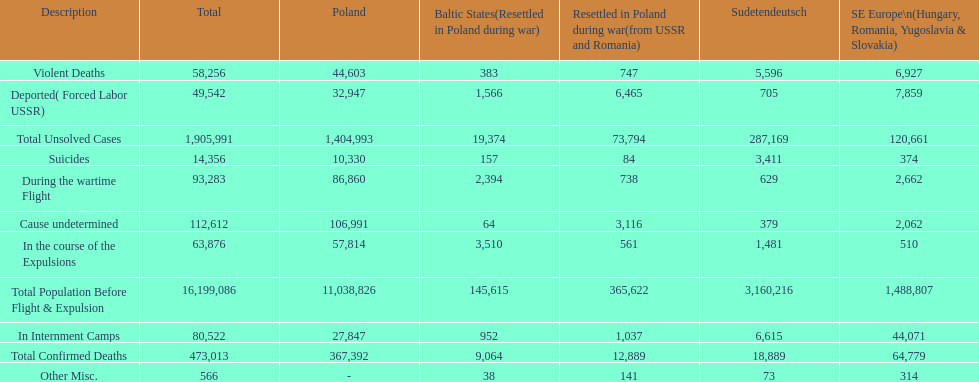What is the difference between suicides in poland and sudetendeutsch? 6919. Give me the full table as a dictionary. {'header': ['Description', 'Total', 'Poland', 'Baltic States(Resettled in Poland during war)', 'Resettled in Poland during war(from USSR and Romania)', 'Sudetendeutsch', 'SE Europe\\n(Hungary, Romania, Yugoslavia & Slovakia)'], 'rows': [['Violent Deaths', '58,256', '44,603', '383', '747', '5,596', '6,927'], ['Deported( Forced Labor USSR)', '49,542', '32,947', '1,566', '6,465', '705', '7,859'], ['Total Unsolved Cases', '1,905,991', '1,404,993', '19,374', '73,794', '287,169', '120,661'], ['Suicides', '14,356', '10,330', '157', '84', '3,411', '374'], ['During the wartime Flight', '93,283', '86,860', '2,394', '738', '629', '2,662'], ['Cause undetermined', '112,612', '106,991', '64', '3,116', '379', '2,062'], ['In the course of the Expulsions', '63,876', '57,814', '3,510', '561', '1,481', '510'], ['Total Population Before Flight & Expulsion', '16,199,086', '11,038,826', '145,615', '365,622', '3,160,216', '1,488,807'], ['In Internment Camps', '80,522', '27,847', '952', '1,037', '6,615', '44,071'], ['Total Confirmed Deaths', '473,013', '367,392', '9,064', '12,889', '18,889', '64,779'], ['Other Misc.', '566', '-', '38', '141', '73', '314']]} 